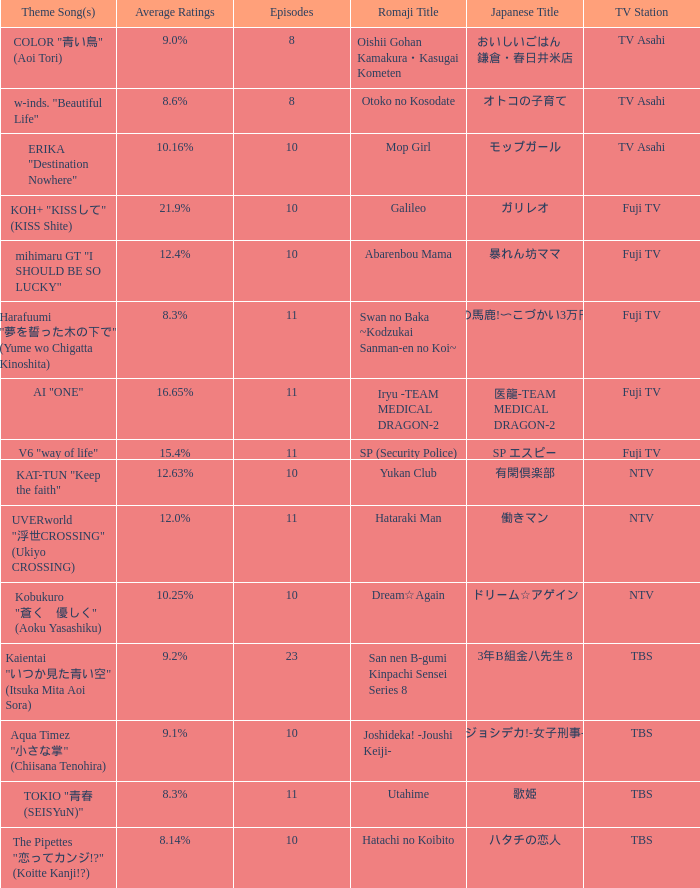What Episode has a Theme Song of koh+ "kissして" (kiss shite)? 10.0. 